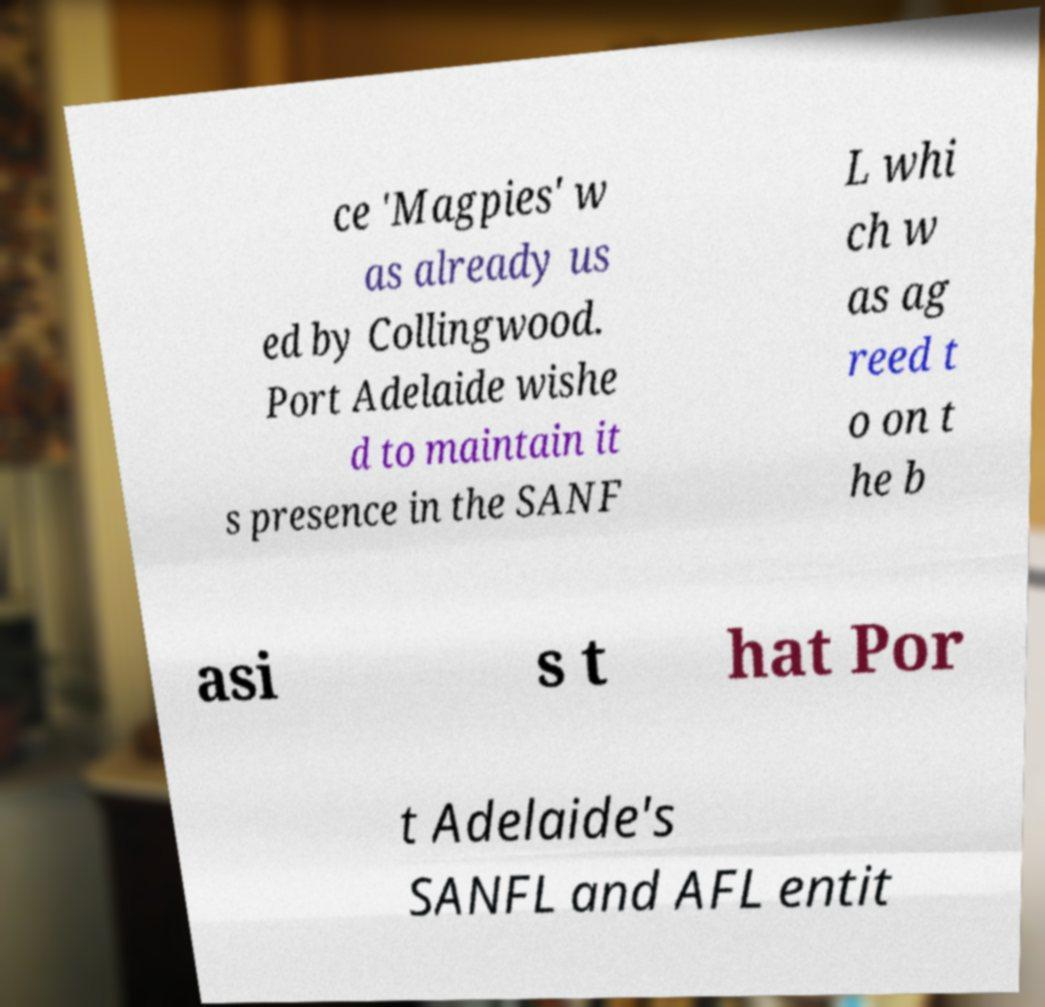Please read and relay the text visible in this image. What does it say? ce 'Magpies' w as already us ed by Collingwood. Port Adelaide wishe d to maintain it s presence in the SANF L whi ch w as ag reed t o on t he b asi s t hat Por t Adelaide's SANFL and AFL entit 